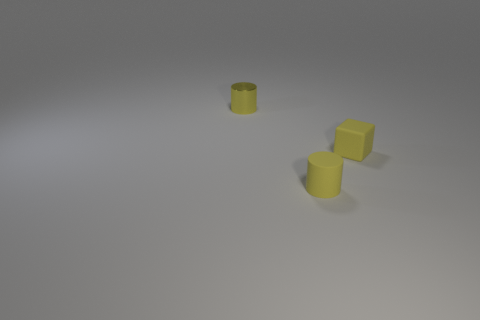Add 1 cylinders. How many objects exist? 4 Subtract all cylinders. How many objects are left? 1 Subtract 1 blocks. How many blocks are left? 0 Subtract all green cubes. Subtract all yellow balls. How many cubes are left? 1 Subtract all tiny cubes. Subtract all tiny metallic objects. How many objects are left? 1 Add 3 cylinders. How many cylinders are left? 5 Add 1 small yellow matte cylinders. How many small yellow matte cylinders exist? 2 Subtract 0 blue balls. How many objects are left? 3 